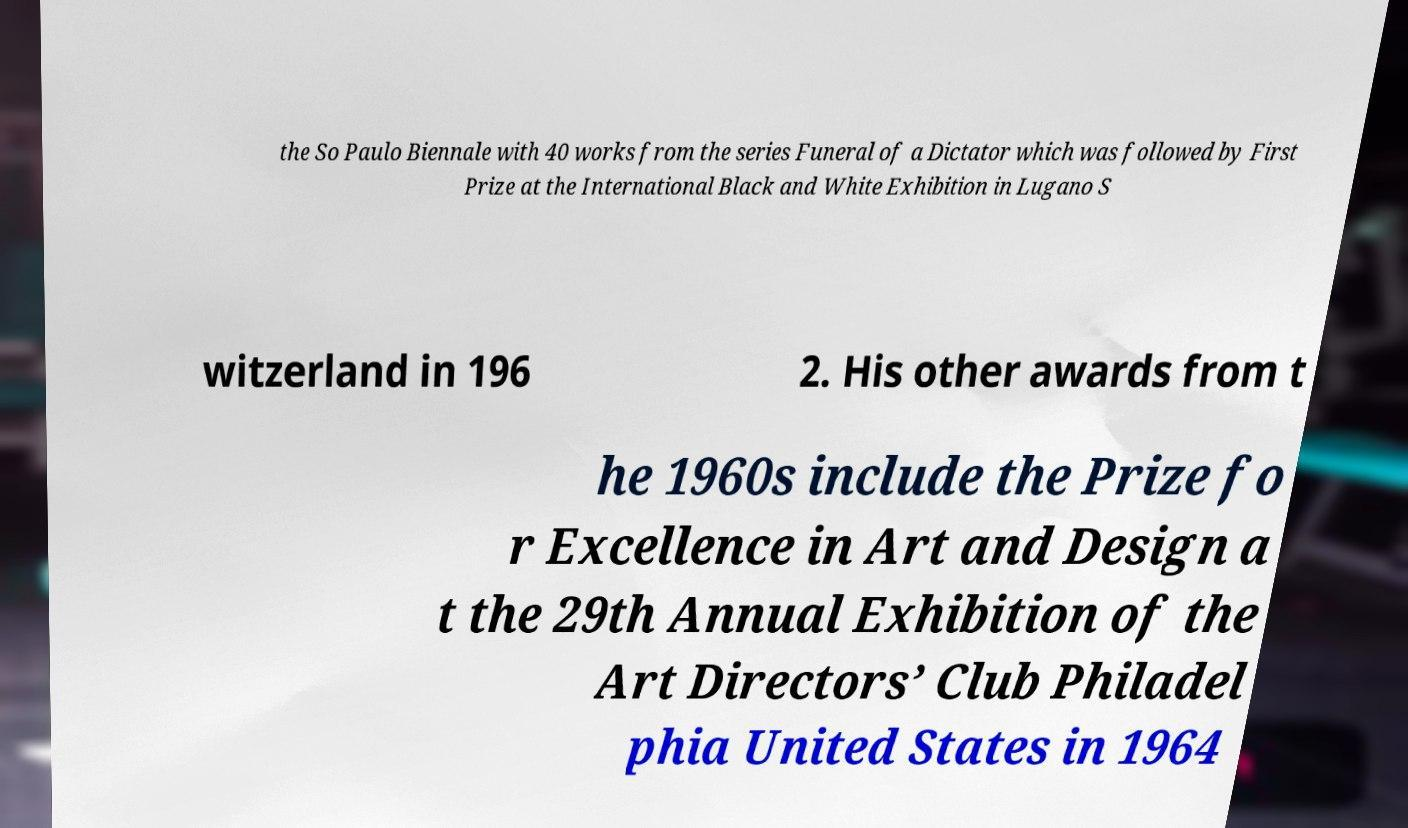Please identify and transcribe the text found in this image. the So Paulo Biennale with 40 works from the series Funeral of a Dictator which was followed by First Prize at the International Black and White Exhibition in Lugano S witzerland in 196 2. His other awards from t he 1960s include the Prize fo r Excellence in Art and Design a t the 29th Annual Exhibition of the Art Directors’ Club Philadel phia United States in 1964 